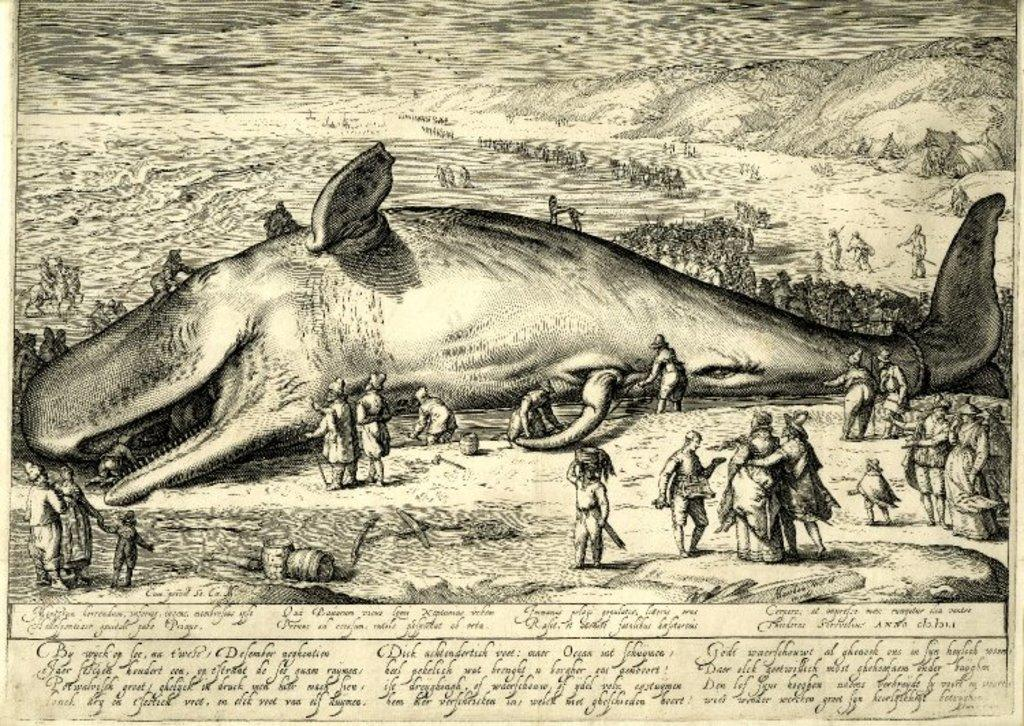What type of animals can be seen in the image? There are fish in the image. Can you describe the people in the image? There is a group of people in the image. What are some people doing in the image? Some people are holding something. What is the paper with writing on it used for? The paper with writing on it is likely used for communication or documentation. What type of fog can be seen in the image? There is no fog present in the image. How does the crow interact with the fish in the image? There is no crow present in the image, so it cannot interact with the fish. 